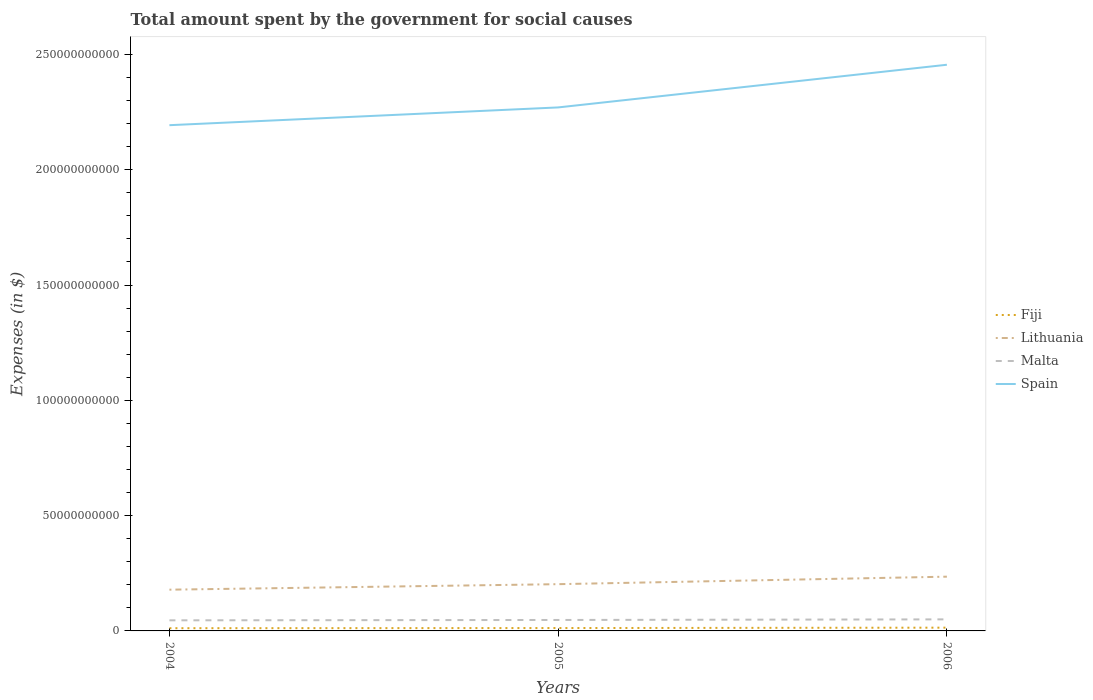How many different coloured lines are there?
Offer a terse response. 4. Across all years, what is the maximum amount spent for social causes by the government in Fiji?
Make the answer very short. 1.18e+09. In which year was the amount spent for social causes by the government in Lithuania maximum?
Your response must be concise. 2004. What is the total amount spent for social causes by the government in Spain in the graph?
Ensure brevity in your answer.  -2.62e+1. What is the difference between the highest and the second highest amount spent for social causes by the government in Fiji?
Offer a very short reply. 2.35e+08. Is the amount spent for social causes by the government in Spain strictly greater than the amount spent for social causes by the government in Malta over the years?
Your response must be concise. No. How many lines are there?
Make the answer very short. 4. How many years are there in the graph?
Provide a short and direct response. 3. What is the difference between two consecutive major ticks on the Y-axis?
Offer a very short reply. 5.00e+1. Are the values on the major ticks of Y-axis written in scientific E-notation?
Make the answer very short. No. Does the graph contain grids?
Your answer should be compact. No. How are the legend labels stacked?
Keep it short and to the point. Vertical. What is the title of the graph?
Offer a terse response. Total amount spent by the government for social causes. What is the label or title of the X-axis?
Your answer should be very brief. Years. What is the label or title of the Y-axis?
Give a very brief answer. Expenses (in $). What is the Expenses (in $) of Fiji in 2004?
Your answer should be compact. 1.18e+09. What is the Expenses (in $) in Lithuania in 2004?
Give a very brief answer. 1.79e+1. What is the Expenses (in $) in Malta in 2004?
Ensure brevity in your answer.  4.59e+09. What is the Expenses (in $) of Spain in 2004?
Your response must be concise. 2.19e+11. What is the Expenses (in $) of Fiji in 2005?
Your answer should be very brief. 1.25e+09. What is the Expenses (in $) in Lithuania in 2005?
Keep it short and to the point. 2.03e+1. What is the Expenses (in $) of Malta in 2005?
Your response must be concise. 4.75e+09. What is the Expenses (in $) of Spain in 2005?
Provide a short and direct response. 2.27e+11. What is the Expenses (in $) in Fiji in 2006?
Make the answer very short. 1.41e+09. What is the Expenses (in $) of Lithuania in 2006?
Your answer should be compact. 2.35e+1. What is the Expenses (in $) in Malta in 2006?
Offer a very short reply. 5.01e+09. What is the Expenses (in $) in Spain in 2006?
Your answer should be compact. 2.46e+11. Across all years, what is the maximum Expenses (in $) of Fiji?
Keep it short and to the point. 1.41e+09. Across all years, what is the maximum Expenses (in $) of Lithuania?
Your answer should be very brief. 2.35e+1. Across all years, what is the maximum Expenses (in $) of Malta?
Offer a very short reply. 5.01e+09. Across all years, what is the maximum Expenses (in $) of Spain?
Offer a terse response. 2.46e+11. Across all years, what is the minimum Expenses (in $) in Fiji?
Offer a terse response. 1.18e+09. Across all years, what is the minimum Expenses (in $) of Lithuania?
Your answer should be compact. 1.79e+1. Across all years, what is the minimum Expenses (in $) in Malta?
Make the answer very short. 4.59e+09. Across all years, what is the minimum Expenses (in $) of Spain?
Your response must be concise. 2.19e+11. What is the total Expenses (in $) in Fiji in the graph?
Your response must be concise. 3.84e+09. What is the total Expenses (in $) in Lithuania in the graph?
Keep it short and to the point. 6.17e+1. What is the total Expenses (in $) in Malta in the graph?
Provide a succinct answer. 1.44e+1. What is the total Expenses (in $) of Spain in the graph?
Ensure brevity in your answer.  6.92e+11. What is the difference between the Expenses (in $) of Fiji in 2004 and that in 2005?
Your answer should be compact. -6.75e+07. What is the difference between the Expenses (in $) of Lithuania in 2004 and that in 2005?
Your response must be concise. -2.39e+09. What is the difference between the Expenses (in $) in Malta in 2004 and that in 2005?
Keep it short and to the point. -1.56e+08. What is the difference between the Expenses (in $) in Spain in 2004 and that in 2005?
Provide a succinct answer. -7.71e+09. What is the difference between the Expenses (in $) of Fiji in 2004 and that in 2006?
Your answer should be very brief. -2.35e+08. What is the difference between the Expenses (in $) of Lithuania in 2004 and that in 2006?
Provide a succinct answer. -5.64e+09. What is the difference between the Expenses (in $) in Malta in 2004 and that in 2006?
Your response must be concise. -4.18e+08. What is the difference between the Expenses (in $) of Spain in 2004 and that in 2006?
Offer a terse response. -2.62e+1. What is the difference between the Expenses (in $) in Fiji in 2005 and that in 2006?
Your response must be concise. -1.67e+08. What is the difference between the Expenses (in $) in Lithuania in 2005 and that in 2006?
Provide a succinct answer. -3.25e+09. What is the difference between the Expenses (in $) of Malta in 2005 and that in 2006?
Your answer should be compact. -2.62e+08. What is the difference between the Expenses (in $) of Spain in 2005 and that in 2006?
Keep it short and to the point. -1.85e+1. What is the difference between the Expenses (in $) of Fiji in 2004 and the Expenses (in $) of Lithuania in 2005?
Give a very brief answer. -1.91e+1. What is the difference between the Expenses (in $) in Fiji in 2004 and the Expenses (in $) in Malta in 2005?
Offer a very short reply. -3.57e+09. What is the difference between the Expenses (in $) of Fiji in 2004 and the Expenses (in $) of Spain in 2005?
Your answer should be compact. -2.26e+11. What is the difference between the Expenses (in $) of Lithuania in 2004 and the Expenses (in $) of Malta in 2005?
Keep it short and to the point. 1.31e+1. What is the difference between the Expenses (in $) of Lithuania in 2004 and the Expenses (in $) of Spain in 2005?
Your answer should be very brief. -2.09e+11. What is the difference between the Expenses (in $) of Malta in 2004 and the Expenses (in $) of Spain in 2005?
Provide a short and direct response. -2.22e+11. What is the difference between the Expenses (in $) in Fiji in 2004 and the Expenses (in $) in Lithuania in 2006?
Provide a succinct answer. -2.24e+1. What is the difference between the Expenses (in $) in Fiji in 2004 and the Expenses (in $) in Malta in 2006?
Offer a terse response. -3.83e+09. What is the difference between the Expenses (in $) of Fiji in 2004 and the Expenses (in $) of Spain in 2006?
Provide a short and direct response. -2.44e+11. What is the difference between the Expenses (in $) in Lithuania in 2004 and the Expenses (in $) in Malta in 2006?
Your response must be concise. 1.29e+1. What is the difference between the Expenses (in $) of Lithuania in 2004 and the Expenses (in $) of Spain in 2006?
Your answer should be very brief. -2.28e+11. What is the difference between the Expenses (in $) of Malta in 2004 and the Expenses (in $) of Spain in 2006?
Provide a short and direct response. -2.41e+11. What is the difference between the Expenses (in $) of Fiji in 2005 and the Expenses (in $) of Lithuania in 2006?
Provide a succinct answer. -2.23e+1. What is the difference between the Expenses (in $) of Fiji in 2005 and the Expenses (in $) of Malta in 2006?
Give a very brief answer. -3.77e+09. What is the difference between the Expenses (in $) of Fiji in 2005 and the Expenses (in $) of Spain in 2006?
Offer a very short reply. -2.44e+11. What is the difference between the Expenses (in $) in Lithuania in 2005 and the Expenses (in $) in Malta in 2006?
Your answer should be very brief. 1.53e+1. What is the difference between the Expenses (in $) in Lithuania in 2005 and the Expenses (in $) in Spain in 2006?
Give a very brief answer. -2.25e+11. What is the difference between the Expenses (in $) in Malta in 2005 and the Expenses (in $) in Spain in 2006?
Provide a short and direct response. -2.41e+11. What is the average Expenses (in $) in Fiji per year?
Offer a terse response. 1.28e+09. What is the average Expenses (in $) of Lithuania per year?
Offer a very short reply. 2.06e+1. What is the average Expenses (in $) in Malta per year?
Your response must be concise. 4.78e+09. What is the average Expenses (in $) in Spain per year?
Ensure brevity in your answer.  2.31e+11. In the year 2004, what is the difference between the Expenses (in $) of Fiji and Expenses (in $) of Lithuania?
Keep it short and to the point. -1.67e+1. In the year 2004, what is the difference between the Expenses (in $) in Fiji and Expenses (in $) in Malta?
Ensure brevity in your answer.  -3.42e+09. In the year 2004, what is the difference between the Expenses (in $) of Fiji and Expenses (in $) of Spain?
Your answer should be very brief. -2.18e+11. In the year 2004, what is the difference between the Expenses (in $) in Lithuania and Expenses (in $) in Malta?
Provide a short and direct response. 1.33e+1. In the year 2004, what is the difference between the Expenses (in $) of Lithuania and Expenses (in $) of Spain?
Your answer should be very brief. -2.01e+11. In the year 2004, what is the difference between the Expenses (in $) of Malta and Expenses (in $) of Spain?
Your answer should be compact. -2.15e+11. In the year 2005, what is the difference between the Expenses (in $) in Fiji and Expenses (in $) in Lithuania?
Offer a very short reply. -1.90e+1. In the year 2005, what is the difference between the Expenses (in $) in Fiji and Expenses (in $) in Malta?
Offer a very short reply. -3.50e+09. In the year 2005, what is the difference between the Expenses (in $) in Fiji and Expenses (in $) in Spain?
Provide a short and direct response. -2.26e+11. In the year 2005, what is the difference between the Expenses (in $) of Lithuania and Expenses (in $) of Malta?
Provide a succinct answer. 1.55e+1. In the year 2005, what is the difference between the Expenses (in $) in Lithuania and Expenses (in $) in Spain?
Offer a very short reply. -2.07e+11. In the year 2005, what is the difference between the Expenses (in $) of Malta and Expenses (in $) of Spain?
Your response must be concise. -2.22e+11. In the year 2006, what is the difference between the Expenses (in $) of Fiji and Expenses (in $) of Lithuania?
Provide a succinct answer. -2.21e+1. In the year 2006, what is the difference between the Expenses (in $) of Fiji and Expenses (in $) of Malta?
Your response must be concise. -3.60e+09. In the year 2006, what is the difference between the Expenses (in $) in Fiji and Expenses (in $) in Spain?
Provide a short and direct response. -2.44e+11. In the year 2006, what is the difference between the Expenses (in $) of Lithuania and Expenses (in $) of Malta?
Give a very brief answer. 1.85e+1. In the year 2006, what is the difference between the Expenses (in $) in Lithuania and Expenses (in $) in Spain?
Provide a short and direct response. -2.22e+11. In the year 2006, what is the difference between the Expenses (in $) of Malta and Expenses (in $) of Spain?
Your answer should be compact. -2.41e+11. What is the ratio of the Expenses (in $) of Fiji in 2004 to that in 2005?
Offer a very short reply. 0.95. What is the ratio of the Expenses (in $) in Lithuania in 2004 to that in 2005?
Ensure brevity in your answer.  0.88. What is the ratio of the Expenses (in $) in Malta in 2004 to that in 2005?
Your answer should be compact. 0.97. What is the ratio of the Expenses (in $) in Spain in 2004 to that in 2005?
Your response must be concise. 0.97. What is the ratio of the Expenses (in $) in Fiji in 2004 to that in 2006?
Make the answer very short. 0.83. What is the ratio of the Expenses (in $) in Lithuania in 2004 to that in 2006?
Give a very brief answer. 0.76. What is the ratio of the Expenses (in $) in Malta in 2004 to that in 2006?
Provide a succinct answer. 0.92. What is the ratio of the Expenses (in $) of Spain in 2004 to that in 2006?
Give a very brief answer. 0.89. What is the ratio of the Expenses (in $) in Fiji in 2005 to that in 2006?
Your answer should be very brief. 0.88. What is the ratio of the Expenses (in $) of Lithuania in 2005 to that in 2006?
Offer a terse response. 0.86. What is the ratio of the Expenses (in $) in Malta in 2005 to that in 2006?
Ensure brevity in your answer.  0.95. What is the ratio of the Expenses (in $) in Spain in 2005 to that in 2006?
Your answer should be very brief. 0.92. What is the difference between the highest and the second highest Expenses (in $) in Fiji?
Keep it short and to the point. 1.67e+08. What is the difference between the highest and the second highest Expenses (in $) of Lithuania?
Offer a very short reply. 3.25e+09. What is the difference between the highest and the second highest Expenses (in $) in Malta?
Give a very brief answer. 2.62e+08. What is the difference between the highest and the second highest Expenses (in $) in Spain?
Offer a terse response. 1.85e+1. What is the difference between the highest and the lowest Expenses (in $) of Fiji?
Give a very brief answer. 2.35e+08. What is the difference between the highest and the lowest Expenses (in $) in Lithuania?
Ensure brevity in your answer.  5.64e+09. What is the difference between the highest and the lowest Expenses (in $) in Malta?
Keep it short and to the point. 4.18e+08. What is the difference between the highest and the lowest Expenses (in $) of Spain?
Offer a terse response. 2.62e+1. 